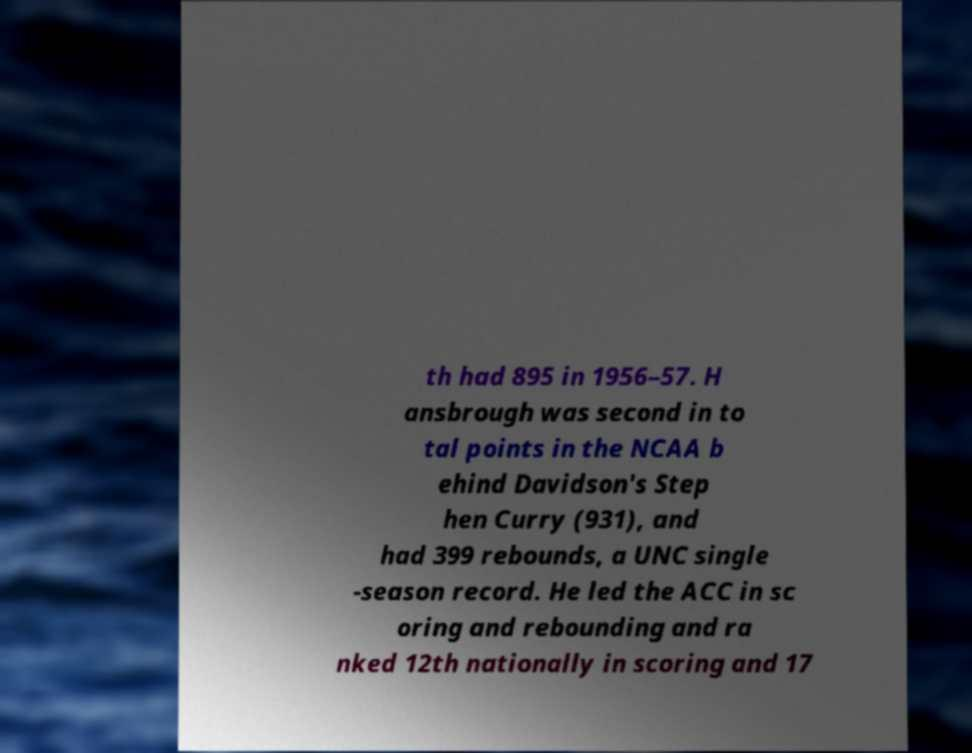Please read and relay the text visible in this image. What does it say? th had 895 in 1956–57. H ansbrough was second in to tal points in the NCAA b ehind Davidson's Step hen Curry (931), and had 399 rebounds, a UNC single -season record. He led the ACC in sc oring and rebounding and ra nked 12th nationally in scoring and 17 